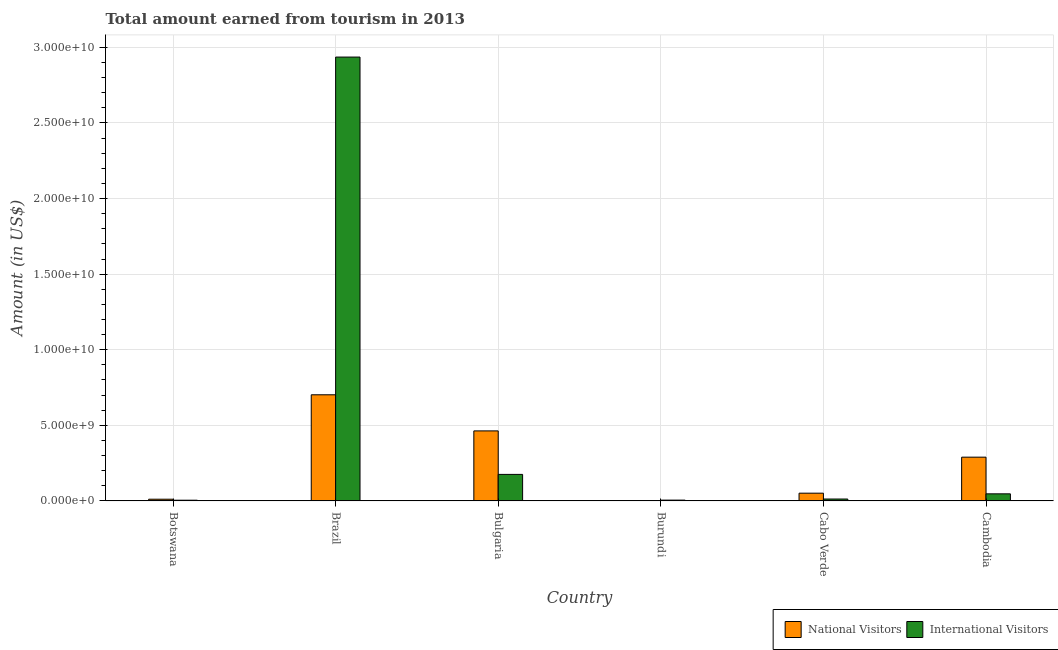How many groups of bars are there?
Your answer should be compact. 6. Are the number of bars per tick equal to the number of legend labels?
Offer a terse response. Yes. How many bars are there on the 1st tick from the left?
Ensure brevity in your answer.  2. What is the label of the 5th group of bars from the left?
Provide a short and direct response. Cabo Verde. What is the amount earned from national visitors in Cambodia?
Your answer should be very brief. 2.90e+09. Across all countries, what is the maximum amount earned from national visitors?
Offer a very short reply. 7.02e+09. Across all countries, what is the minimum amount earned from national visitors?
Make the answer very short. 3.09e+06. In which country was the amount earned from national visitors minimum?
Your answer should be very brief. Burundi. What is the total amount earned from national visitors in the graph?
Provide a short and direct response. 1.52e+1. What is the difference between the amount earned from national visitors in Botswana and that in Cambodia?
Offer a terse response. -2.78e+09. What is the difference between the amount earned from international visitors in Bulgaria and the amount earned from national visitors in Botswana?
Your answer should be very brief. 1.64e+09. What is the average amount earned from national visitors per country?
Ensure brevity in your answer.  2.53e+09. What is the difference between the amount earned from national visitors and amount earned from international visitors in Bulgaria?
Keep it short and to the point. 2.88e+09. What is the ratio of the amount earned from national visitors in Burundi to that in Cambodia?
Make the answer very short. 0. Is the amount earned from international visitors in Botswana less than that in Cabo Verde?
Offer a very short reply. Yes. Is the difference between the amount earned from national visitors in Brazil and Cabo Verde greater than the difference between the amount earned from international visitors in Brazil and Cabo Verde?
Offer a terse response. No. What is the difference between the highest and the second highest amount earned from international visitors?
Your response must be concise. 2.76e+1. What is the difference between the highest and the lowest amount earned from national visitors?
Ensure brevity in your answer.  7.02e+09. In how many countries, is the amount earned from national visitors greater than the average amount earned from national visitors taken over all countries?
Provide a succinct answer. 3. What does the 1st bar from the left in Burundi represents?
Ensure brevity in your answer.  National Visitors. What does the 1st bar from the right in Burundi represents?
Your response must be concise. International Visitors. How many bars are there?
Offer a very short reply. 12. How many countries are there in the graph?
Your response must be concise. 6. Where does the legend appear in the graph?
Give a very brief answer. Bottom right. How many legend labels are there?
Your answer should be very brief. 2. How are the legend labels stacked?
Your answer should be very brief. Horizontal. What is the title of the graph?
Keep it short and to the point. Total amount earned from tourism in 2013. What is the label or title of the X-axis?
Your answer should be very brief. Country. What is the Amount (in US$) of National Visitors in Botswana?
Give a very brief answer. 1.13e+08. What is the Amount (in US$) in International Visitors in Botswana?
Your answer should be very brief. 4.72e+07. What is the Amount (in US$) of National Visitors in Brazil?
Offer a terse response. 7.02e+09. What is the Amount (in US$) in International Visitors in Brazil?
Offer a terse response. 2.94e+1. What is the Amount (in US$) in National Visitors in Bulgaria?
Provide a succinct answer. 4.63e+09. What is the Amount (in US$) of International Visitors in Bulgaria?
Your answer should be very brief. 1.76e+09. What is the Amount (in US$) of National Visitors in Burundi?
Make the answer very short. 3.09e+06. What is the Amount (in US$) of International Visitors in Burundi?
Keep it short and to the point. 5.40e+07. What is the Amount (in US$) of National Visitors in Cabo Verde?
Your answer should be compact. 5.12e+08. What is the Amount (in US$) of International Visitors in Cabo Verde?
Keep it short and to the point. 1.26e+08. What is the Amount (in US$) of National Visitors in Cambodia?
Provide a succinct answer. 2.90e+09. What is the Amount (in US$) in International Visitors in Cambodia?
Your response must be concise. 4.69e+08. Across all countries, what is the maximum Amount (in US$) of National Visitors?
Keep it short and to the point. 7.02e+09. Across all countries, what is the maximum Amount (in US$) of International Visitors?
Make the answer very short. 2.94e+1. Across all countries, what is the minimum Amount (in US$) in National Visitors?
Offer a very short reply. 3.09e+06. Across all countries, what is the minimum Amount (in US$) of International Visitors?
Provide a succinct answer. 4.72e+07. What is the total Amount (in US$) of National Visitors in the graph?
Offer a very short reply. 1.52e+1. What is the total Amount (in US$) of International Visitors in the graph?
Offer a very short reply. 3.18e+1. What is the difference between the Amount (in US$) in National Visitors in Botswana and that in Brazil?
Your response must be concise. -6.91e+09. What is the difference between the Amount (in US$) in International Visitors in Botswana and that in Brazil?
Give a very brief answer. -2.93e+1. What is the difference between the Amount (in US$) of National Visitors in Botswana and that in Bulgaria?
Offer a very short reply. -4.52e+09. What is the difference between the Amount (in US$) of International Visitors in Botswana and that in Bulgaria?
Ensure brevity in your answer.  -1.71e+09. What is the difference between the Amount (in US$) in National Visitors in Botswana and that in Burundi?
Keep it short and to the point. 1.10e+08. What is the difference between the Amount (in US$) in International Visitors in Botswana and that in Burundi?
Your response must be concise. -6.80e+06. What is the difference between the Amount (in US$) in National Visitors in Botswana and that in Cabo Verde?
Give a very brief answer. -3.99e+08. What is the difference between the Amount (in US$) in International Visitors in Botswana and that in Cabo Verde?
Your answer should be very brief. -7.88e+07. What is the difference between the Amount (in US$) in National Visitors in Botswana and that in Cambodia?
Provide a short and direct response. -2.78e+09. What is the difference between the Amount (in US$) of International Visitors in Botswana and that in Cambodia?
Provide a succinct answer. -4.22e+08. What is the difference between the Amount (in US$) of National Visitors in Brazil and that in Bulgaria?
Ensure brevity in your answer.  2.39e+09. What is the difference between the Amount (in US$) in International Visitors in Brazil and that in Bulgaria?
Make the answer very short. 2.76e+1. What is the difference between the Amount (in US$) of National Visitors in Brazil and that in Burundi?
Your answer should be very brief. 7.02e+09. What is the difference between the Amount (in US$) of International Visitors in Brazil and that in Burundi?
Your answer should be compact. 2.93e+1. What is the difference between the Amount (in US$) of National Visitors in Brazil and that in Cabo Verde?
Your response must be concise. 6.51e+09. What is the difference between the Amount (in US$) in International Visitors in Brazil and that in Cabo Verde?
Ensure brevity in your answer.  2.92e+1. What is the difference between the Amount (in US$) of National Visitors in Brazil and that in Cambodia?
Ensure brevity in your answer.  4.13e+09. What is the difference between the Amount (in US$) of International Visitors in Brazil and that in Cambodia?
Your answer should be very brief. 2.89e+1. What is the difference between the Amount (in US$) in National Visitors in Bulgaria and that in Burundi?
Your answer should be compact. 4.63e+09. What is the difference between the Amount (in US$) in International Visitors in Bulgaria and that in Burundi?
Provide a succinct answer. 1.70e+09. What is the difference between the Amount (in US$) in National Visitors in Bulgaria and that in Cabo Verde?
Make the answer very short. 4.12e+09. What is the difference between the Amount (in US$) of International Visitors in Bulgaria and that in Cabo Verde?
Provide a short and direct response. 1.63e+09. What is the difference between the Amount (in US$) in National Visitors in Bulgaria and that in Cambodia?
Offer a terse response. 1.74e+09. What is the difference between the Amount (in US$) of International Visitors in Bulgaria and that in Cambodia?
Make the answer very short. 1.29e+09. What is the difference between the Amount (in US$) in National Visitors in Burundi and that in Cabo Verde?
Provide a succinct answer. -5.09e+08. What is the difference between the Amount (in US$) of International Visitors in Burundi and that in Cabo Verde?
Give a very brief answer. -7.20e+07. What is the difference between the Amount (in US$) of National Visitors in Burundi and that in Cambodia?
Ensure brevity in your answer.  -2.89e+09. What is the difference between the Amount (in US$) of International Visitors in Burundi and that in Cambodia?
Ensure brevity in your answer.  -4.15e+08. What is the difference between the Amount (in US$) of National Visitors in Cabo Verde and that in Cambodia?
Offer a terse response. -2.38e+09. What is the difference between the Amount (in US$) of International Visitors in Cabo Verde and that in Cambodia?
Give a very brief answer. -3.43e+08. What is the difference between the Amount (in US$) in National Visitors in Botswana and the Amount (in US$) in International Visitors in Brazil?
Give a very brief answer. -2.92e+1. What is the difference between the Amount (in US$) of National Visitors in Botswana and the Amount (in US$) of International Visitors in Bulgaria?
Make the answer very short. -1.64e+09. What is the difference between the Amount (in US$) in National Visitors in Botswana and the Amount (in US$) in International Visitors in Burundi?
Provide a succinct answer. 5.90e+07. What is the difference between the Amount (in US$) in National Visitors in Botswana and the Amount (in US$) in International Visitors in Cabo Verde?
Provide a succinct answer. -1.30e+07. What is the difference between the Amount (in US$) of National Visitors in Botswana and the Amount (in US$) of International Visitors in Cambodia?
Provide a succinct answer. -3.56e+08. What is the difference between the Amount (in US$) of National Visitors in Brazil and the Amount (in US$) of International Visitors in Bulgaria?
Offer a terse response. 5.27e+09. What is the difference between the Amount (in US$) in National Visitors in Brazil and the Amount (in US$) in International Visitors in Burundi?
Keep it short and to the point. 6.97e+09. What is the difference between the Amount (in US$) in National Visitors in Brazil and the Amount (in US$) in International Visitors in Cabo Verde?
Make the answer very short. 6.90e+09. What is the difference between the Amount (in US$) of National Visitors in Brazil and the Amount (in US$) of International Visitors in Cambodia?
Your answer should be very brief. 6.55e+09. What is the difference between the Amount (in US$) in National Visitors in Bulgaria and the Amount (in US$) in International Visitors in Burundi?
Provide a succinct answer. 4.58e+09. What is the difference between the Amount (in US$) in National Visitors in Bulgaria and the Amount (in US$) in International Visitors in Cabo Verde?
Provide a short and direct response. 4.51e+09. What is the difference between the Amount (in US$) in National Visitors in Bulgaria and the Amount (in US$) in International Visitors in Cambodia?
Keep it short and to the point. 4.16e+09. What is the difference between the Amount (in US$) of National Visitors in Burundi and the Amount (in US$) of International Visitors in Cabo Verde?
Make the answer very short. -1.23e+08. What is the difference between the Amount (in US$) of National Visitors in Burundi and the Amount (in US$) of International Visitors in Cambodia?
Provide a succinct answer. -4.66e+08. What is the difference between the Amount (in US$) of National Visitors in Cabo Verde and the Amount (in US$) of International Visitors in Cambodia?
Give a very brief answer. 4.30e+07. What is the average Amount (in US$) in National Visitors per country?
Offer a very short reply. 2.53e+09. What is the average Amount (in US$) of International Visitors per country?
Provide a short and direct response. 5.30e+09. What is the difference between the Amount (in US$) of National Visitors and Amount (in US$) of International Visitors in Botswana?
Ensure brevity in your answer.  6.58e+07. What is the difference between the Amount (in US$) of National Visitors and Amount (in US$) of International Visitors in Brazil?
Ensure brevity in your answer.  -2.23e+1. What is the difference between the Amount (in US$) of National Visitors and Amount (in US$) of International Visitors in Bulgaria?
Offer a very short reply. 2.88e+09. What is the difference between the Amount (in US$) in National Visitors and Amount (in US$) in International Visitors in Burundi?
Provide a succinct answer. -5.09e+07. What is the difference between the Amount (in US$) in National Visitors and Amount (in US$) in International Visitors in Cabo Verde?
Provide a succinct answer. 3.86e+08. What is the difference between the Amount (in US$) of National Visitors and Amount (in US$) of International Visitors in Cambodia?
Provide a short and direct response. 2.43e+09. What is the ratio of the Amount (in US$) in National Visitors in Botswana to that in Brazil?
Make the answer very short. 0.02. What is the ratio of the Amount (in US$) in International Visitors in Botswana to that in Brazil?
Make the answer very short. 0. What is the ratio of the Amount (in US$) of National Visitors in Botswana to that in Bulgaria?
Provide a succinct answer. 0.02. What is the ratio of the Amount (in US$) of International Visitors in Botswana to that in Bulgaria?
Your answer should be compact. 0.03. What is the ratio of the Amount (in US$) of National Visitors in Botswana to that in Burundi?
Give a very brief answer. 36.57. What is the ratio of the Amount (in US$) in International Visitors in Botswana to that in Burundi?
Your answer should be very brief. 0.87. What is the ratio of the Amount (in US$) in National Visitors in Botswana to that in Cabo Verde?
Your answer should be compact. 0.22. What is the ratio of the Amount (in US$) of International Visitors in Botswana to that in Cabo Verde?
Your answer should be very brief. 0.37. What is the ratio of the Amount (in US$) in National Visitors in Botswana to that in Cambodia?
Your answer should be very brief. 0.04. What is the ratio of the Amount (in US$) of International Visitors in Botswana to that in Cambodia?
Your response must be concise. 0.1. What is the ratio of the Amount (in US$) in National Visitors in Brazil to that in Bulgaria?
Ensure brevity in your answer.  1.52. What is the ratio of the Amount (in US$) in International Visitors in Brazil to that in Bulgaria?
Provide a succinct answer. 16.73. What is the ratio of the Amount (in US$) in National Visitors in Brazil to that in Burundi?
Make the answer very short. 2272.17. What is the ratio of the Amount (in US$) of International Visitors in Brazil to that in Burundi?
Provide a succinct answer. 543.72. What is the ratio of the Amount (in US$) in National Visitors in Brazil to that in Cabo Verde?
Your answer should be compact. 13.71. What is the ratio of the Amount (in US$) in International Visitors in Brazil to that in Cabo Verde?
Ensure brevity in your answer.  233.02. What is the ratio of the Amount (in US$) of National Visitors in Brazil to that in Cambodia?
Your answer should be compact. 2.43. What is the ratio of the Amount (in US$) of International Visitors in Brazil to that in Cambodia?
Offer a terse response. 62.6. What is the ratio of the Amount (in US$) of National Visitors in Bulgaria to that in Burundi?
Provide a short and direct response. 1499.03. What is the ratio of the Amount (in US$) of International Visitors in Bulgaria to that in Burundi?
Your answer should be compact. 32.5. What is the ratio of the Amount (in US$) in National Visitors in Bulgaria to that in Cabo Verde?
Make the answer very short. 9.05. What is the ratio of the Amount (in US$) of International Visitors in Bulgaria to that in Cabo Verde?
Your answer should be compact. 13.93. What is the ratio of the Amount (in US$) of National Visitors in Bulgaria to that in Cambodia?
Your response must be concise. 1.6. What is the ratio of the Amount (in US$) in International Visitors in Bulgaria to that in Cambodia?
Your answer should be compact. 3.74. What is the ratio of the Amount (in US$) in National Visitors in Burundi to that in Cabo Verde?
Give a very brief answer. 0.01. What is the ratio of the Amount (in US$) of International Visitors in Burundi to that in Cabo Verde?
Offer a very short reply. 0.43. What is the ratio of the Amount (in US$) of National Visitors in Burundi to that in Cambodia?
Keep it short and to the point. 0. What is the ratio of the Amount (in US$) of International Visitors in Burundi to that in Cambodia?
Your answer should be very brief. 0.12. What is the ratio of the Amount (in US$) in National Visitors in Cabo Verde to that in Cambodia?
Your answer should be very brief. 0.18. What is the ratio of the Amount (in US$) of International Visitors in Cabo Verde to that in Cambodia?
Provide a succinct answer. 0.27. What is the difference between the highest and the second highest Amount (in US$) of National Visitors?
Give a very brief answer. 2.39e+09. What is the difference between the highest and the second highest Amount (in US$) of International Visitors?
Your answer should be very brief. 2.76e+1. What is the difference between the highest and the lowest Amount (in US$) in National Visitors?
Offer a terse response. 7.02e+09. What is the difference between the highest and the lowest Amount (in US$) in International Visitors?
Your answer should be compact. 2.93e+1. 